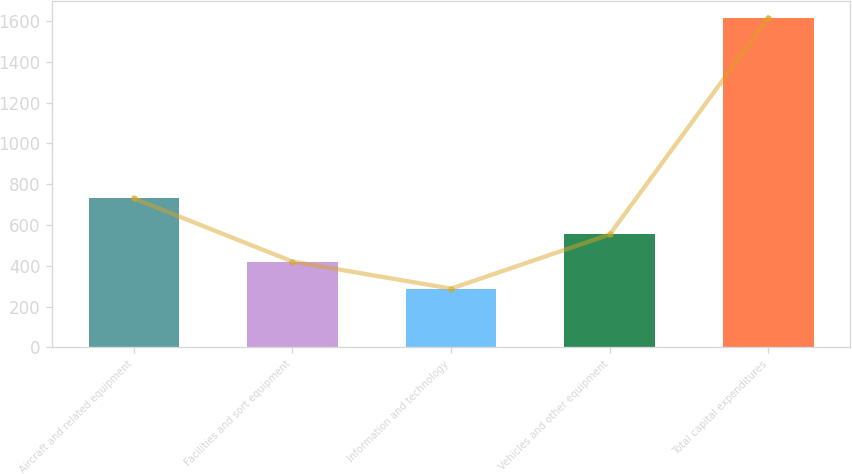<chart> <loc_0><loc_0><loc_500><loc_500><bar_chart><fcel>Aircraft and related equipment<fcel>Facilities and sort equipment<fcel>Information and technology<fcel>Vehicles and other equipment<fcel>Total capital expenditures<nl><fcel>730<fcel>420.7<fcel>288<fcel>553.4<fcel>1615<nl></chart> 